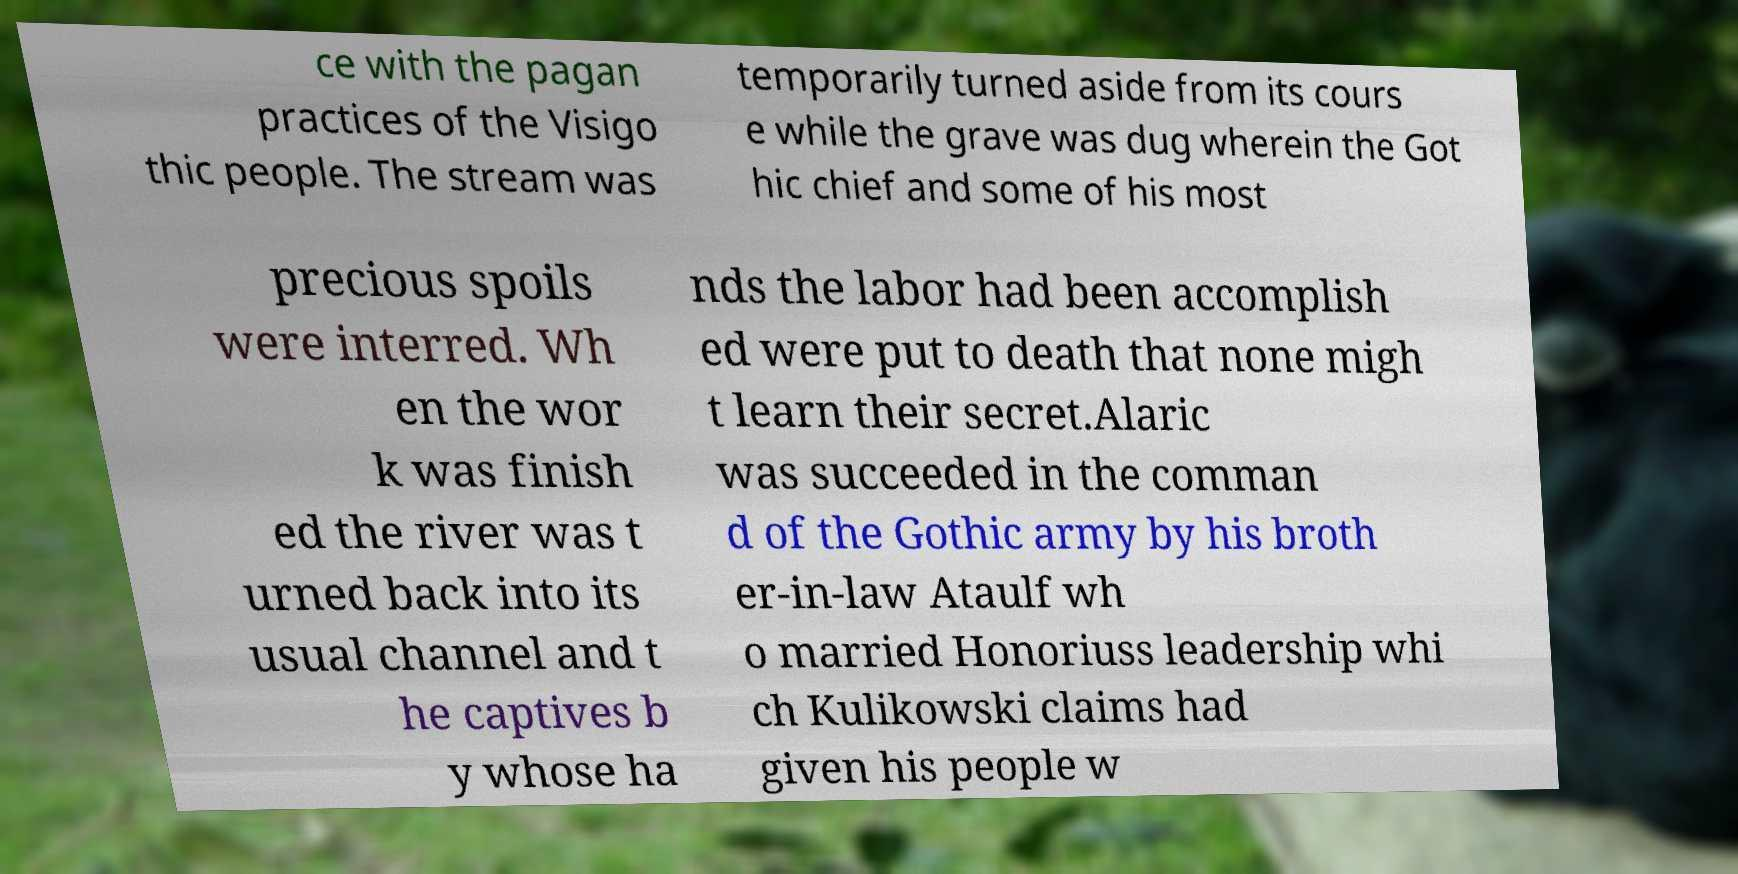Please read and relay the text visible in this image. What does it say? ce with the pagan practices of the Visigo thic people. The stream was temporarily turned aside from its cours e while the grave was dug wherein the Got hic chief and some of his most precious spoils were interred. Wh en the wor k was finish ed the river was t urned back into its usual channel and t he captives b y whose ha nds the labor had been accomplish ed were put to death that none migh t learn their secret.Alaric was succeeded in the comman d of the Gothic army by his broth er-in-law Ataulf wh o married Honoriuss leadership whi ch Kulikowski claims had given his people w 